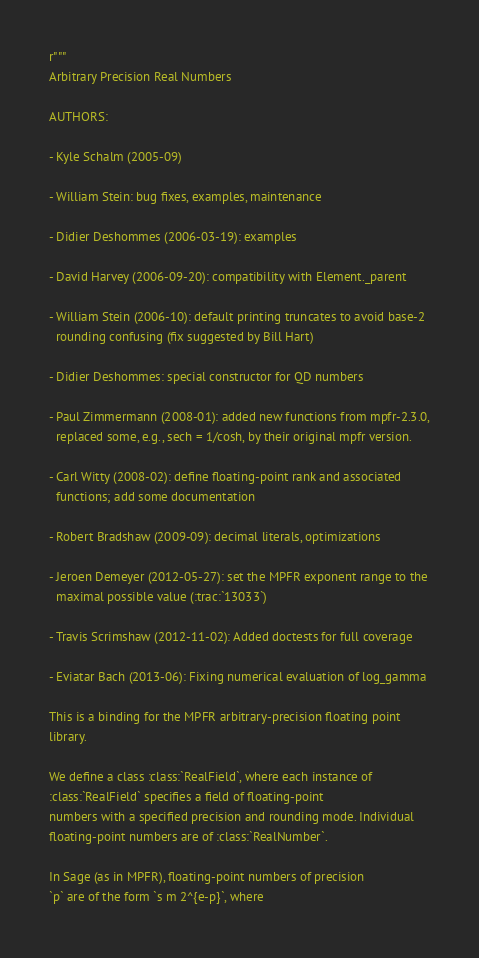Convert code to text. <code><loc_0><loc_0><loc_500><loc_500><_Cython_>r"""
Arbitrary Precision Real Numbers

AUTHORS:

- Kyle Schalm (2005-09)

- William Stein: bug fixes, examples, maintenance

- Didier Deshommes (2006-03-19): examples

- David Harvey (2006-09-20): compatibility with Element._parent

- William Stein (2006-10): default printing truncates to avoid base-2
  rounding confusing (fix suggested by Bill Hart)

- Didier Deshommes: special constructor for QD numbers

- Paul Zimmermann (2008-01): added new functions from mpfr-2.3.0,
  replaced some, e.g., sech = 1/cosh, by their original mpfr version.

- Carl Witty (2008-02): define floating-point rank and associated
  functions; add some documentation

- Robert Bradshaw (2009-09): decimal literals, optimizations

- Jeroen Demeyer (2012-05-27): set the MPFR exponent range to the
  maximal possible value (:trac:`13033`)

- Travis Scrimshaw (2012-11-02): Added doctests for full coverage

- Eviatar Bach (2013-06): Fixing numerical evaluation of log_gamma

This is a binding for the MPFR arbitrary-precision floating point
library.

We define a class :class:`RealField`, where each instance of
:class:`RealField` specifies a field of floating-point
numbers with a specified precision and rounding mode. Individual
floating-point numbers are of :class:`RealNumber`.

In Sage (as in MPFR), floating-point numbers of precision
`p` are of the form `s m 2^{e-p}`, where</code> 